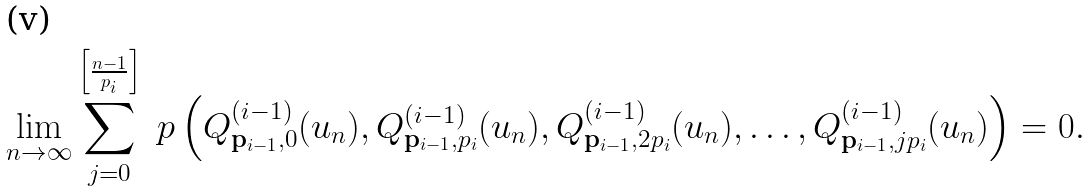<formula> <loc_0><loc_0><loc_500><loc_500>\lim _ { n \to \infty } \sum _ { j = 0 } ^ { \left [ \frac { n - 1 } { p _ { i } } \right ] } \ p \left ( Q ^ { ( i - 1 ) } _ { \mathbf p _ { i - 1 } , 0 } ( u _ { n } ) , Q ^ { ( i - 1 ) } _ { \mathbf p _ { i - 1 } , p _ { i } } ( u _ { n } ) , Q ^ { ( i - 1 ) } _ { \mathbf p _ { i - 1 } , 2 p _ { i } } ( u _ { n } ) , \dots , Q ^ { ( i - 1 ) } _ { \mathbf p _ { i - 1 } , j p _ { i } } ( u _ { n } ) \right ) = 0 .</formula> 